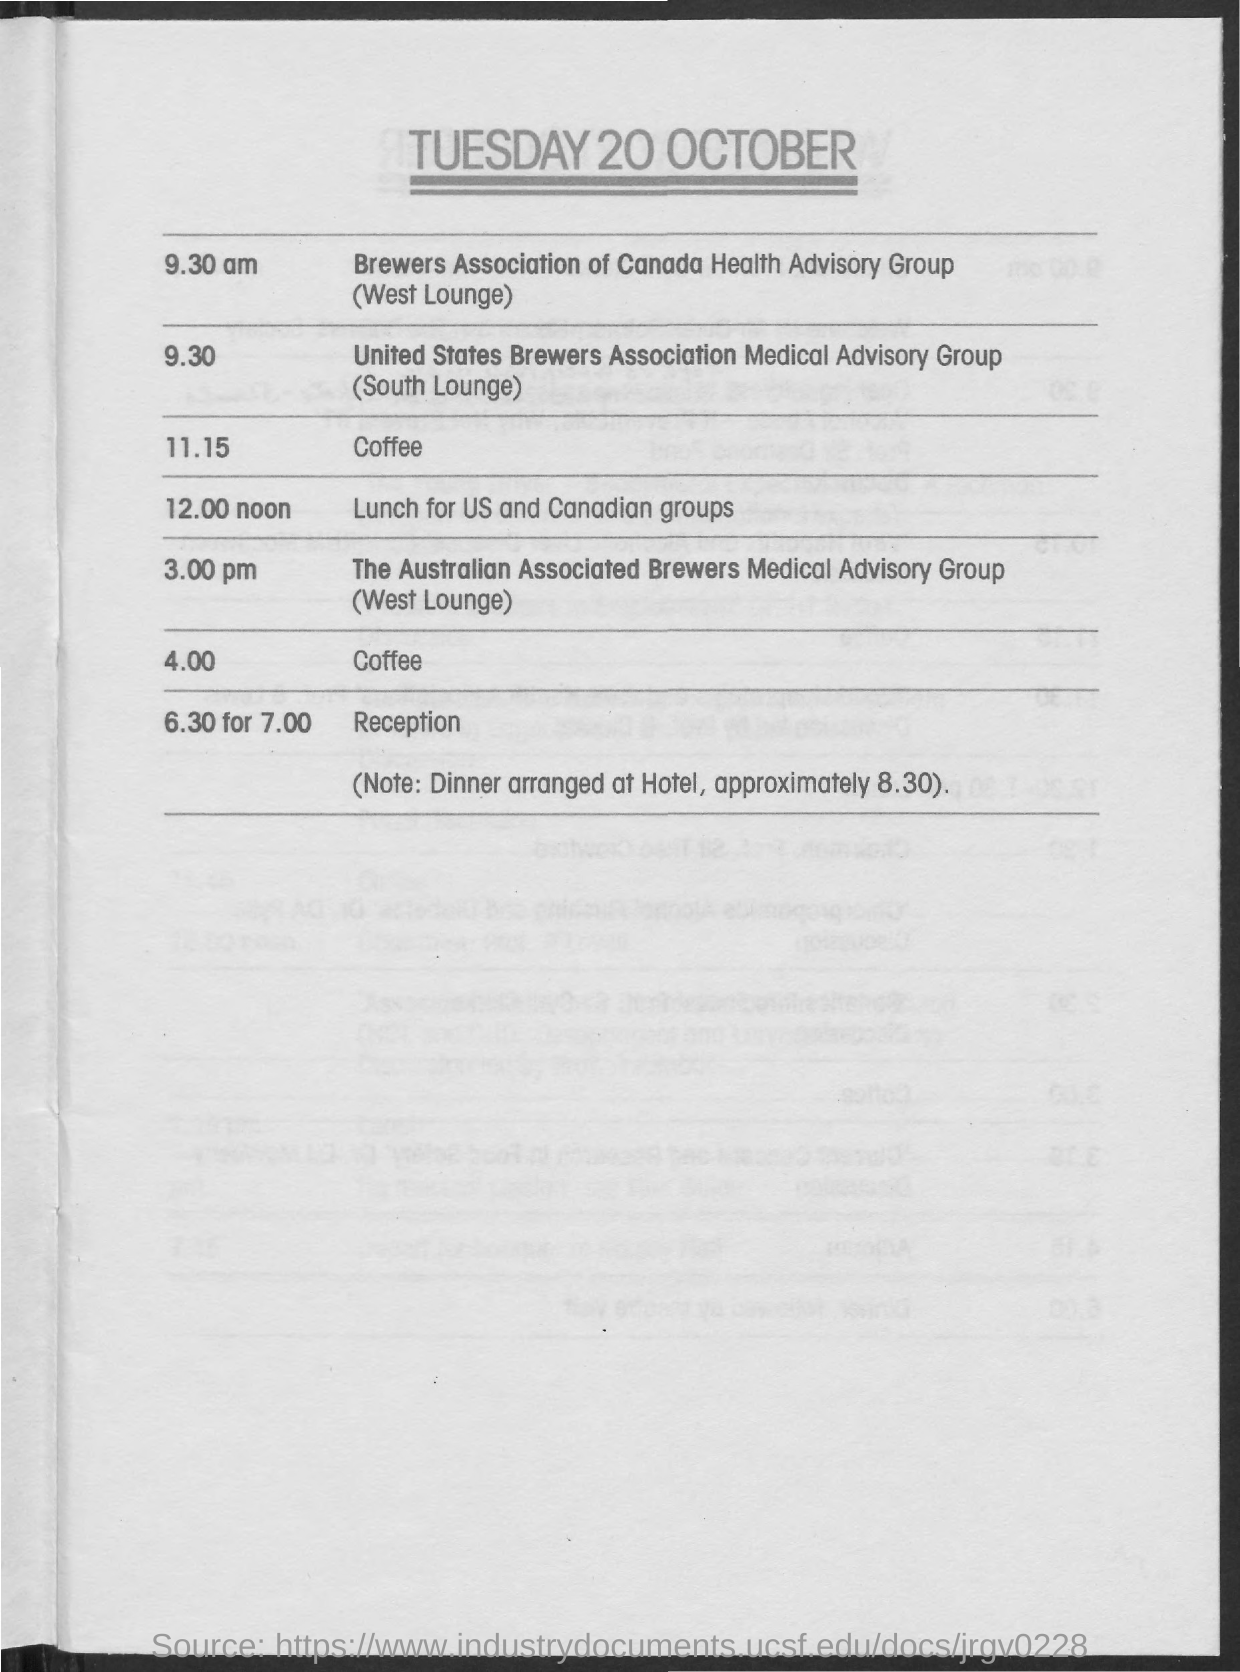Give some essential details in this illustration. The South Lounge has been reserved for the United States Brewers Association Medical Advisory Group. The time scheduled for lunch for the US and Canadian group is 12:00 noon. The scheduling for the Brewers Association Canada Health Advisory Group is set for 9:30 am. A note at the bottom of the schedule indicates that dinner will be arranged at the hotel at approximately 8:30. At 6.30, the scheduled time for Reception, the event will begin at 7.00. 